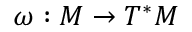<formula> <loc_0><loc_0><loc_500><loc_500>\omega \colon M \to T ^ { * } M</formula> 